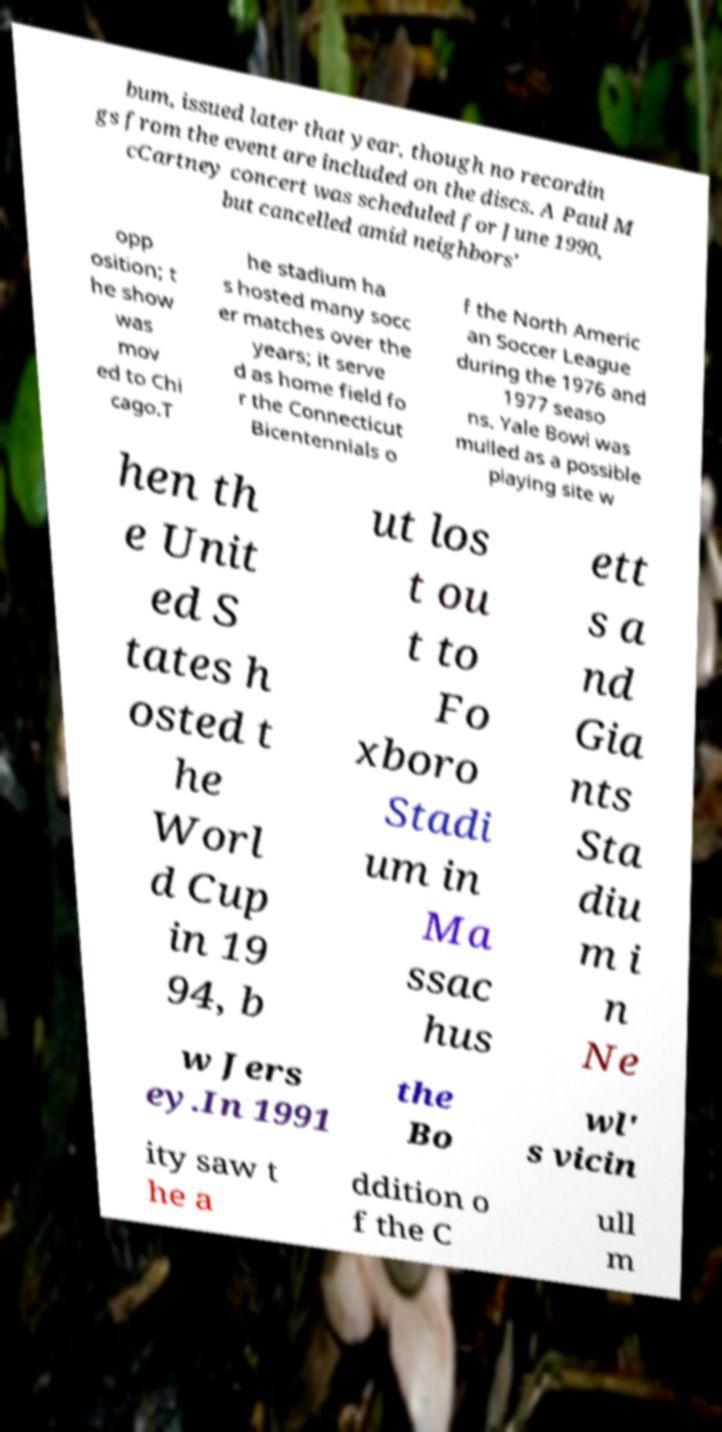For documentation purposes, I need the text within this image transcribed. Could you provide that? bum, issued later that year, though no recordin gs from the event are included on the discs. A Paul M cCartney concert was scheduled for June 1990, but cancelled amid neighbors' opp osition; t he show was mov ed to Chi cago.T he stadium ha s hosted many socc er matches over the years; it serve d as home field fo r the Connecticut Bicentennials o f the North Americ an Soccer League during the 1976 and 1977 seaso ns. Yale Bowl was mulled as a possible playing site w hen th e Unit ed S tates h osted t he Worl d Cup in 19 94, b ut los t ou t to Fo xboro Stadi um in Ma ssac hus ett s a nd Gia nts Sta diu m i n Ne w Jers ey.In 1991 the Bo wl' s vicin ity saw t he a ddition o f the C ull m 